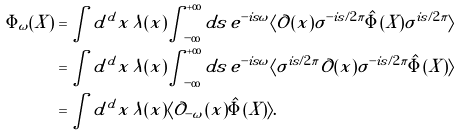<formula> <loc_0><loc_0><loc_500><loc_500>\Phi _ { \omega } ( X ) & = \int d ^ { d } x \, \lambda ( x ) \int _ { - \infty } ^ { + \infty } d s \, e ^ { - i s \omega } \langle \mathcal { O } ( x ) \sigma ^ { - i s / 2 \pi } \hat { \Phi } ( X ) \sigma ^ { i s / 2 \pi } \rangle \\ & = \int d ^ { d } x \, \lambda ( x ) \int _ { - \infty } ^ { + \infty } d s \, e ^ { - i s \omega } \langle \sigma ^ { i s / 2 \pi } \mathcal { O } ( x ) \sigma ^ { - i s / 2 \pi } \hat { \Phi } ( X ) \rangle \\ & = \int d ^ { d } x \, \lambda ( x ) \langle \mathcal { O } _ { - \omega } ( x ) \hat { \Phi } ( X ) \rangle .</formula> 